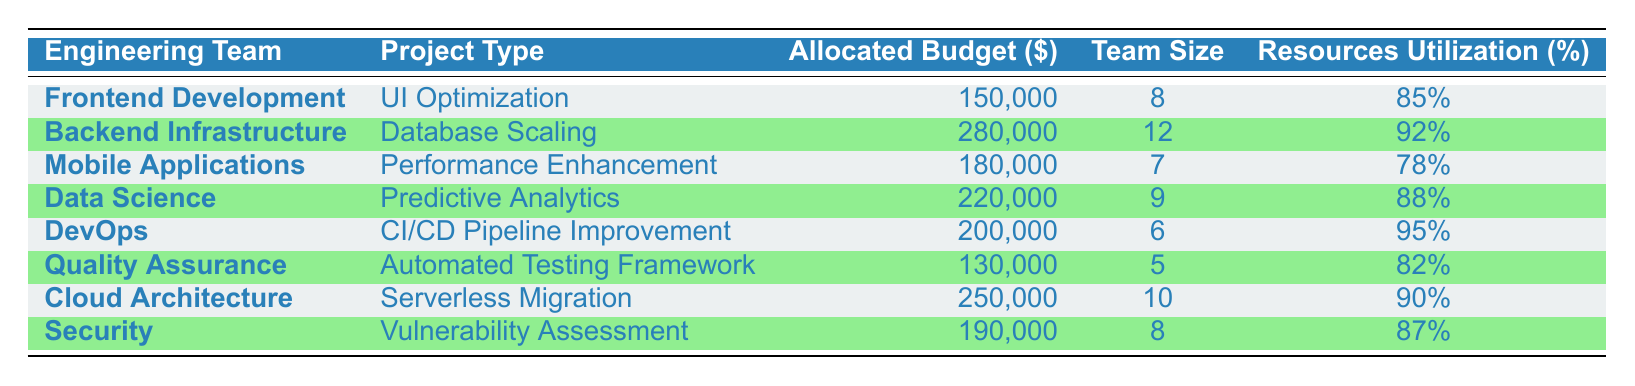What is the allocated budget for the Backend Infrastructure team? The table shows that the allocated budget for the Backend Infrastructure team is listed in the column labeled "Allocated Budget ($)", specifically for this team. The amount is 280,000.
Answer: 280000 Which engineering team has the highest resource utilization percentage? By reviewing the "Resources Utilization (%)" column, the highest percentage is found with the DevOps team, whose utilization is 95%.
Answer: DevOps What is the total budget allocated for all engineering teams? To find the total budget, sum the allocated budgets across all teams: 150000 + 280000 + 180000 + 220000 + 200000 + 130000 + 250000 + 190000 = 1,600,000.
Answer: 1600000 Is the team size of Mobile Applications greater than the team size of Quality Assurance? The team size for Mobile Applications is 7, and for Quality Assurance, it's 5. Since 7 is greater than 5, the statement is true.
Answer: Yes What is the average team size across all engineering teams? To compute the average team size, we first sum the team sizes: 8 + 12 + 7 + 9 + 6 + 5 + 10 + 8 = 65. Then divide by the number of teams, which is 8. The average is 65/8 = 8.125.
Answer: 8.125 Which project type has the lowest allocated budget? By scanning the "Allocated Budget ($)" column, the lowest amount is for the Quality Assurance team's Automated Testing Framework with an allocated budget of 130,000.
Answer: Automated Testing Framework Is it true that the Data Science team has a budget higher than the Cloud Architecture team? Comparing the budgets, the Data Science team has 220000 and Cloud Architecture has 250000. Since 220000 is less than 250000, the statement is false.
Answer: No What is the difference in allocated budget between DevOps and Mobile Applications? The budget for DevOps is 200000 and for Mobile Applications, it is 180000. The difference is calculated as 200000 - 180000 = 20000.
Answer: 20000 